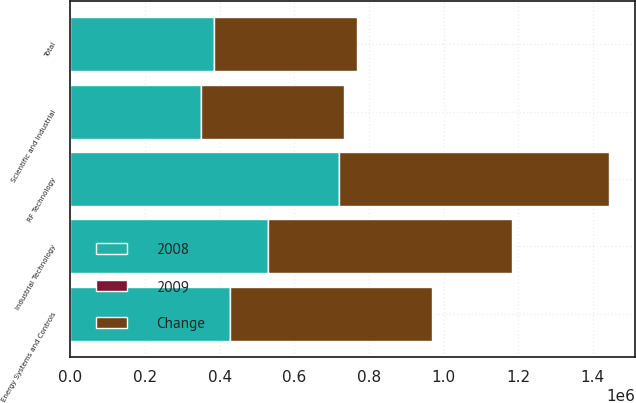<chart> <loc_0><loc_0><loc_500><loc_500><stacked_bar_chart><ecel><fcel>Industrial Technology<fcel>Energy Systems and Controls<fcel>Scientific and Industrial<fcel>RF Technology<fcel>Total<nl><fcel>2008<fcel>528208<fcel>427003<fcel>349132<fcel>719666<fcel>383543<nl><fcel>Change<fcel>656176<fcel>541472<fcel>383543<fcel>722670<fcel>383543<nl><fcel>2009<fcel>19.5<fcel>21.1<fcel>9<fcel>0.4<fcel>12.1<nl></chart> 